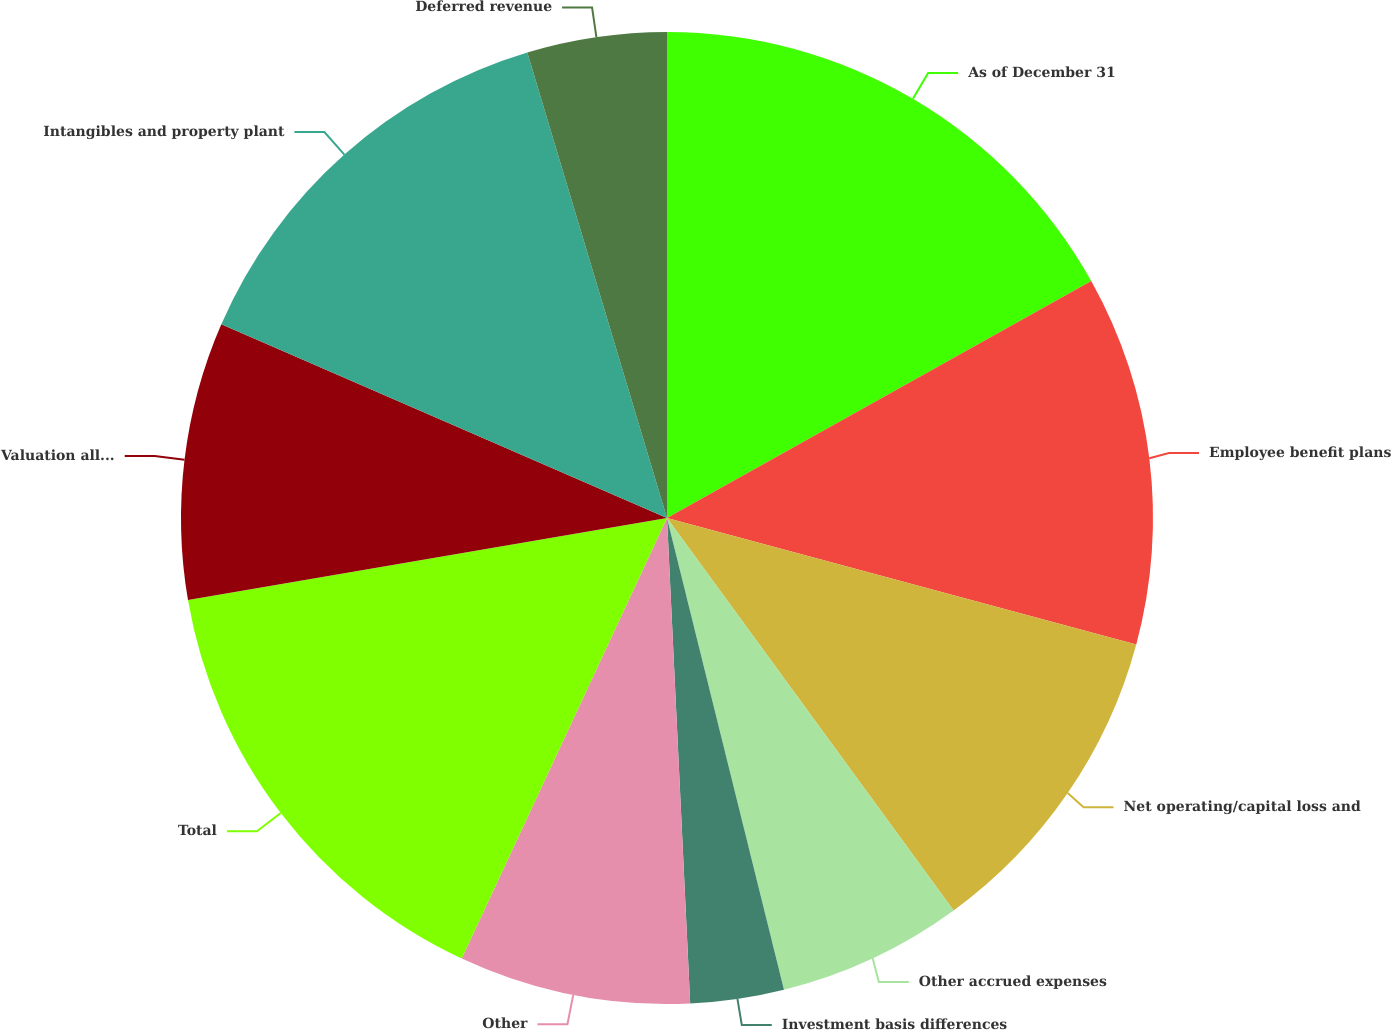<chart> <loc_0><loc_0><loc_500><loc_500><pie_chart><fcel>As of December 31<fcel>Employee benefit plans<fcel>Net operating/capital loss and<fcel>Other accrued expenses<fcel>Investment basis differences<fcel>Other<fcel>Total<fcel>Valuation allowance on<fcel>Intangibles and property plant<fcel>Deferred revenue<nl><fcel>16.89%<fcel>12.3%<fcel>10.77%<fcel>6.17%<fcel>3.11%<fcel>7.7%<fcel>15.36%<fcel>9.23%<fcel>13.83%<fcel>4.64%<nl></chart> 